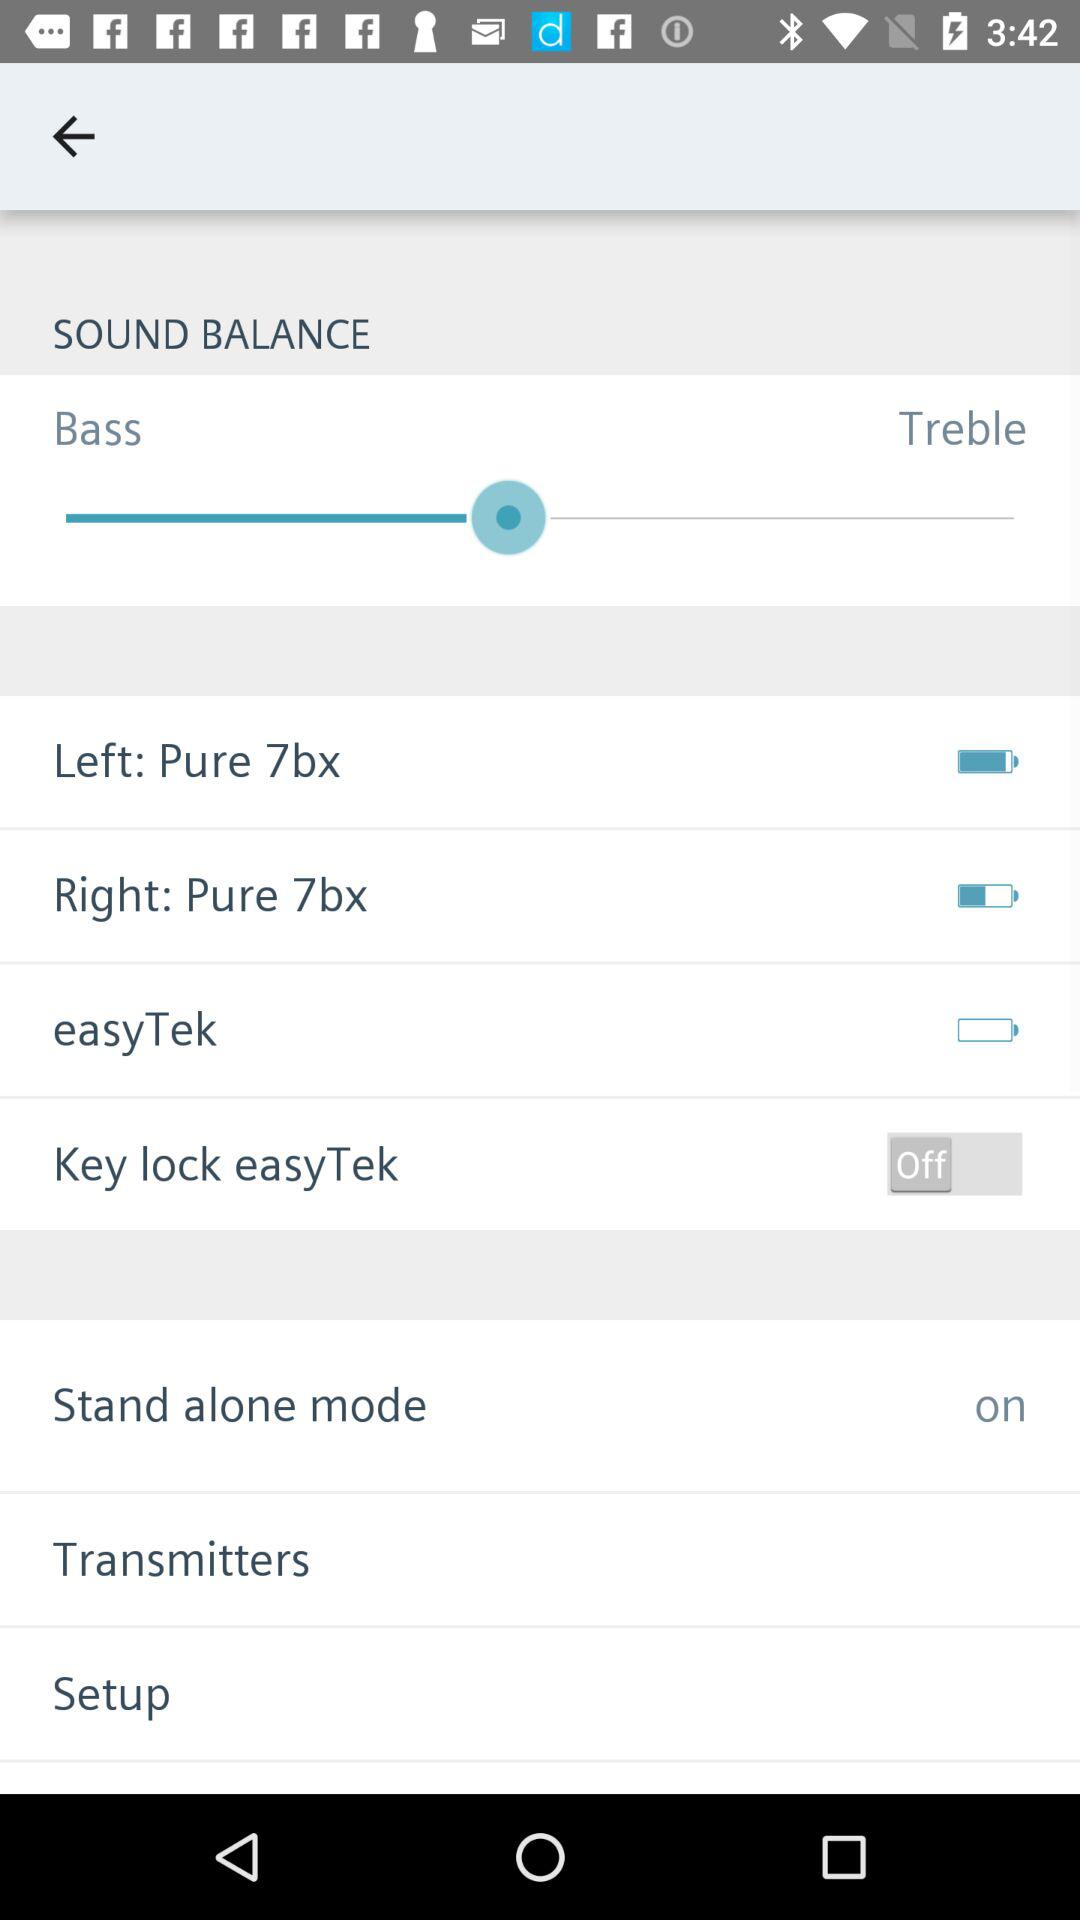What is the status of the "Key lock easyTek"? The status of the "Key lock easyTek" is "off". 